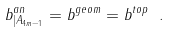Convert formula to latex. <formula><loc_0><loc_0><loc_500><loc_500>b ^ { a n } _ { | A _ { 4 m - 1 } } = b ^ { g e o m } = b ^ { t o p } \ .</formula> 